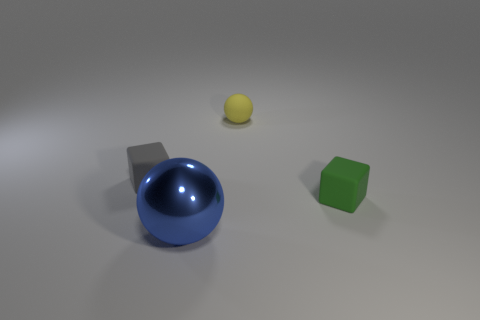Add 4 yellow spheres. How many objects exist? 8 Subtract all large cyan shiny spheres. Subtract all small yellow rubber objects. How many objects are left? 3 Add 2 tiny green cubes. How many tiny green cubes are left? 3 Add 4 tiny green cylinders. How many tiny green cylinders exist? 4 Subtract 0 gray spheres. How many objects are left? 4 